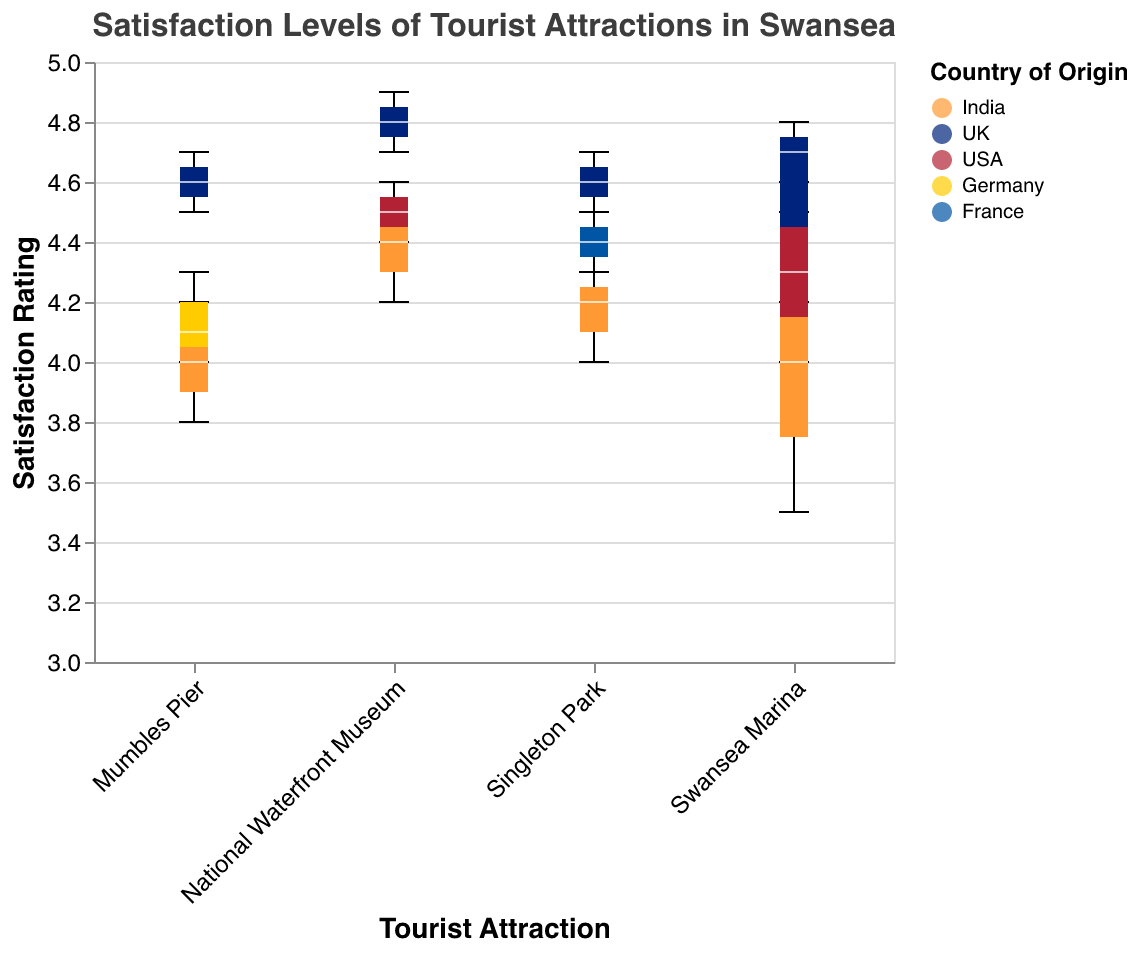What is the title of the plot? The title is displayed on the top of the plot and is written clearly.
Answer: Satisfaction Levels of Tourist Attractions in Swansea What are the names of the tourist attractions shown in the plot? The names of the tourist attractions are displayed on the x-axis at the bottom.
Answer: Swansea Marina, Mumbles Pier, National Waterfront Museum, Singleton Park Which country has the highest median satisfaction rating for National Waterfront Museum? Look at the boxplots for National Waterfront Museum and compare the median lines of different countries. The highest median line belongs to the UK.
Answer: UK Between 'Swansea Marina' and 'Mumbles Pier', which attraction has a higher median satisfaction rating from Indian tourists? Compare the median lines of the Indian tourists' boxplots for 'Swansea Marina' and 'Mumbles Pier'. 'Swansea Marina' has a higher median satisfaction rating.
Answer: Swansea Marina What is the range of satisfaction ratings for USA tourists at Swansea Marina? Look at the boxplot for USA tourists at Swansea Marina. The range is depicted by the distance between the minimum and maximum ticks or whiskers. The minimum rating is 4.0 and the maximum is 4.6.
Answer: 4.0 to 4.6 Which attraction has the highest maximum satisfaction rating overall and from which country? Identify the highest top whisker across all attractions and countries. The National Waterfront Museum has the highest maximum rating of 4.9, from UK tourists.
Answer: National Waterfront Museum, UK How does the median satisfaction level of German tourists at Mumbles Pier compare to the median satisfaction level of French tourists at Singleton Park? Compare the height of the median lines of German tourists at Mumbles Pier and French tourists at Singleton Park. They are approximately the same.
Answer: Equal Which country has the widest range of satisfaction ratings for any attraction? Look for the boxplot with the largest distance between the minimum and maximum ticks or whiskers. The UK at National Waterfront Museum has the widest range from 4.7 to 4.9.
Answer: UK at National Waterfront Museum 